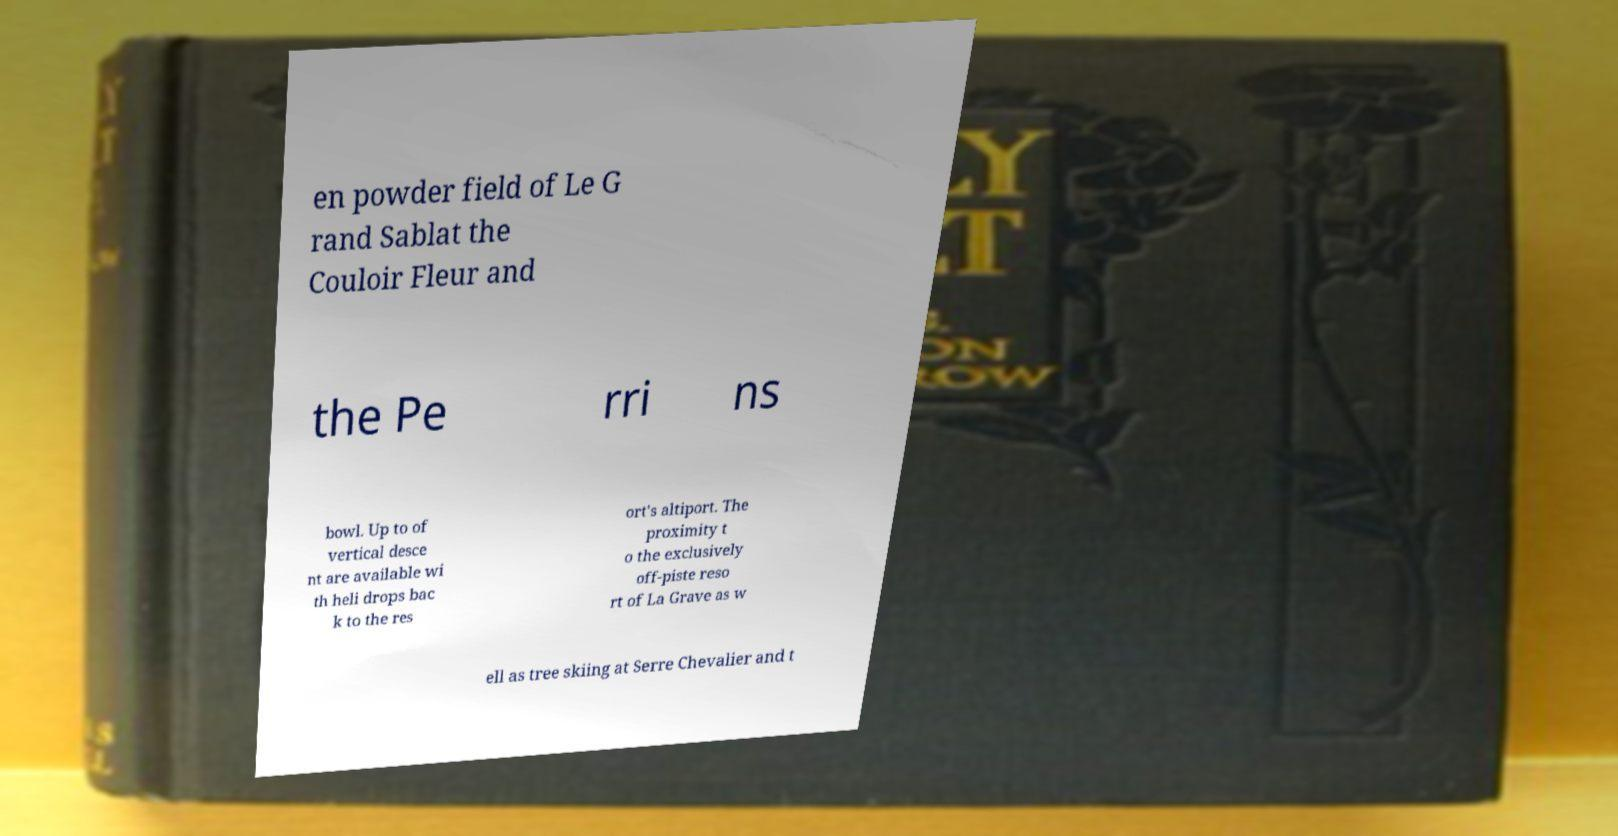Please identify and transcribe the text found in this image. en powder field of Le G rand Sablat the Couloir Fleur and the Pe rri ns bowl. Up to of vertical desce nt are available wi th heli drops bac k to the res ort's altiport. The proximity t o the exclusively off-piste reso rt of La Grave as w ell as tree skiing at Serre Chevalier and t 